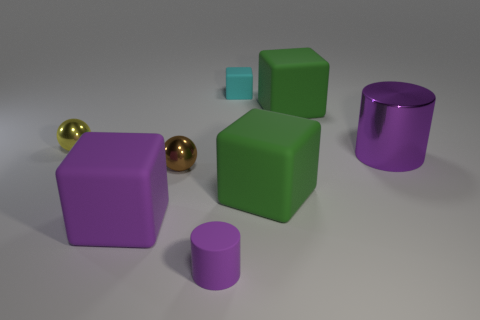Subtract 2 cubes. How many cubes are left? 2 Subtract all gray blocks. Subtract all purple cylinders. How many blocks are left? 4 Add 1 small yellow balls. How many objects exist? 9 Subtract all cylinders. How many objects are left? 6 Add 8 large purple cubes. How many large purple cubes exist? 9 Subtract 0 yellow blocks. How many objects are left? 8 Subtract all tiny cylinders. Subtract all tiny cyan rubber blocks. How many objects are left? 6 Add 3 brown balls. How many brown balls are left? 4 